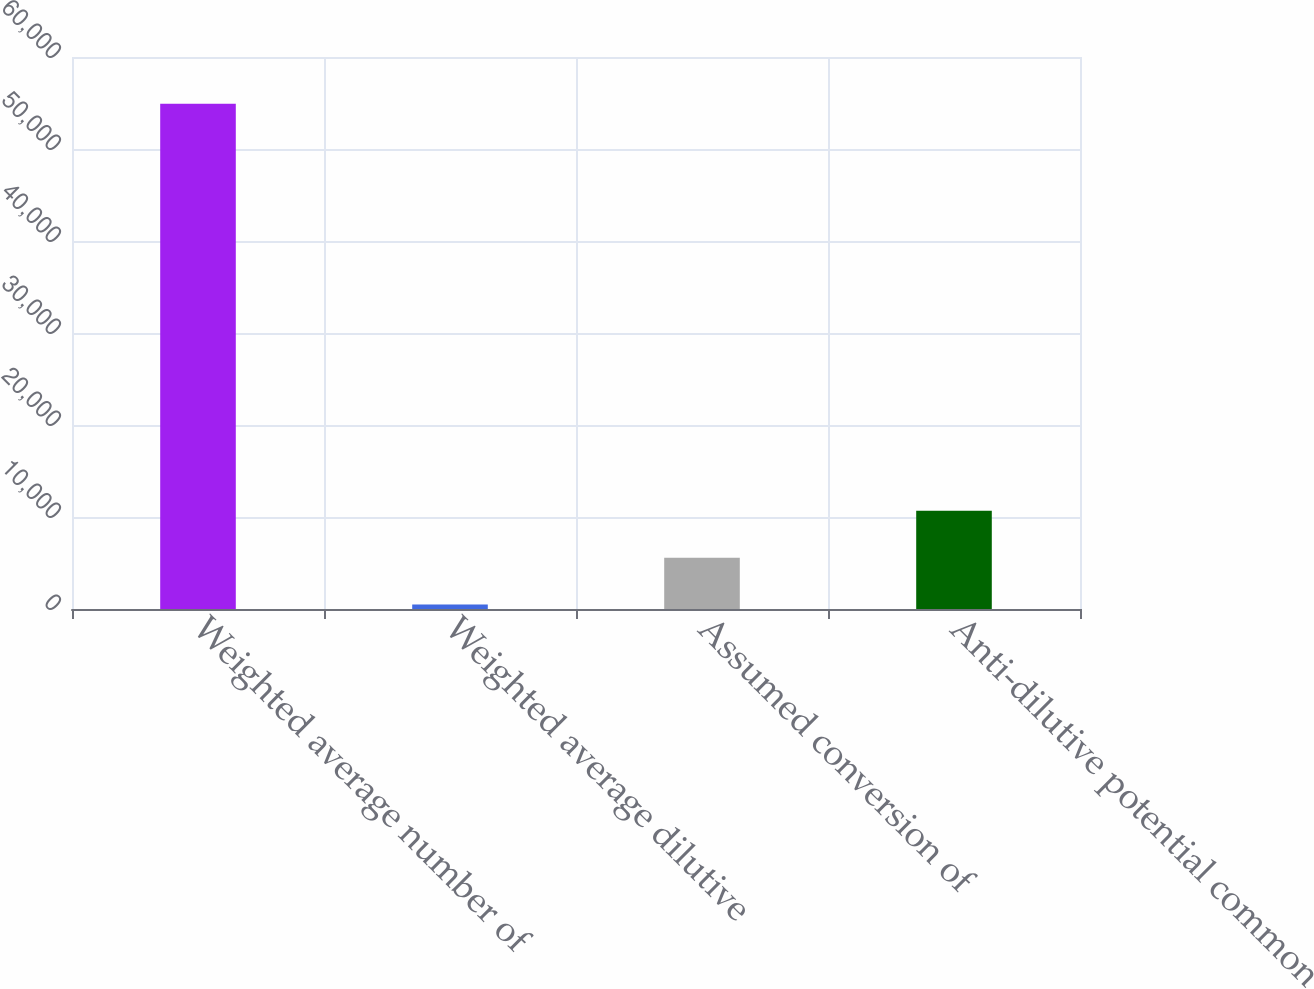Convert chart to OTSL. <chart><loc_0><loc_0><loc_500><loc_500><bar_chart><fcel>Weighted average number of<fcel>Weighted average dilutive<fcel>Assumed conversion of<fcel>Anti-dilutive potential common<nl><fcel>54922.5<fcel>501<fcel>5583.5<fcel>10666<nl></chart> 